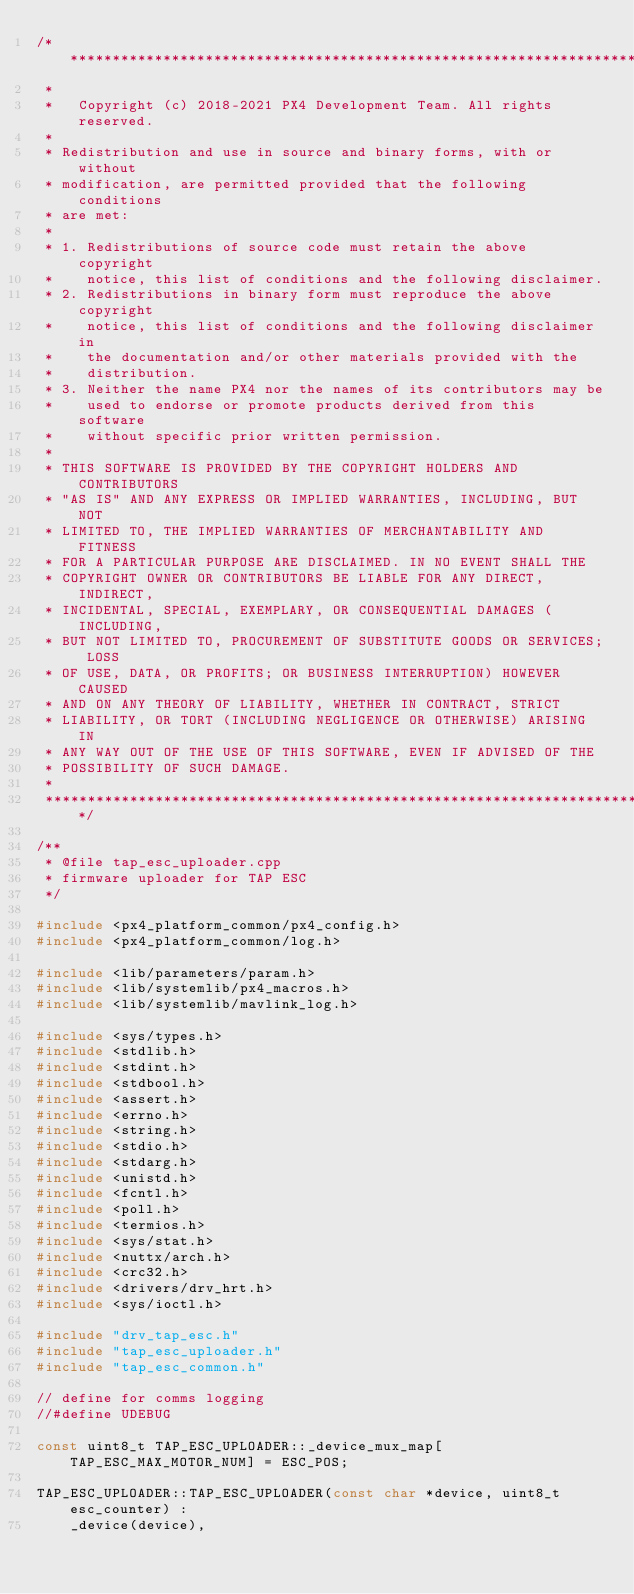<code> <loc_0><loc_0><loc_500><loc_500><_C++_>/****************************************************************************
 *
 *   Copyright (c) 2018-2021 PX4 Development Team. All rights reserved.
 *
 * Redistribution and use in source and binary forms, with or without
 * modification, are permitted provided that the following conditions
 * are met:
 *
 * 1. Redistributions of source code must retain the above copyright
 *    notice, this list of conditions and the following disclaimer.
 * 2. Redistributions in binary form must reproduce the above copyright
 *    notice, this list of conditions and the following disclaimer in
 *    the documentation and/or other materials provided with the
 *    distribution.
 * 3. Neither the name PX4 nor the names of its contributors may be
 *    used to endorse or promote products derived from this software
 *    without specific prior written permission.
 *
 * THIS SOFTWARE IS PROVIDED BY THE COPYRIGHT HOLDERS AND CONTRIBUTORS
 * "AS IS" AND ANY EXPRESS OR IMPLIED WARRANTIES, INCLUDING, BUT NOT
 * LIMITED TO, THE IMPLIED WARRANTIES OF MERCHANTABILITY AND FITNESS
 * FOR A PARTICULAR PURPOSE ARE DISCLAIMED. IN NO EVENT SHALL THE
 * COPYRIGHT OWNER OR CONTRIBUTORS BE LIABLE FOR ANY DIRECT, INDIRECT,
 * INCIDENTAL, SPECIAL, EXEMPLARY, OR CONSEQUENTIAL DAMAGES (INCLUDING,
 * BUT NOT LIMITED TO, PROCUREMENT OF SUBSTITUTE GOODS OR SERVICES; LOSS
 * OF USE, DATA, OR PROFITS; OR BUSINESS INTERRUPTION) HOWEVER CAUSED
 * AND ON ANY THEORY OF LIABILITY, WHETHER IN CONTRACT, STRICT
 * LIABILITY, OR TORT (INCLUDING NEGLIGENCE OR OTHERWISE) ARISING IN
 * ANY WAY OUT OF THE USE OF THIS SOFTWARE, EVEN IF ADVISED OF THE
 * POSSIBILITY OF SUCH DAMAGE.
 *
 ****************************************************************************/

/**
 * @file tap_esc_uploader.cpp
 * firmware uploader for TAP ESC
 */

#include <px4_platform_common/px4_config.h>
#include <px4_platform_common/log.h>

#include <lib/parameters/param.h>
#include <lib/systemlib/px4_macros.h>
#include <lib/systemlib/mavlink_log.h>

#include <sys/types.h>
#include <stdlib.h>
#include <stdint.h>
#include <stdbool.h>
#include <assert.h>
#include <errno.h>
#include <string.h>
#include <stdio.h>
#include <stdarg.h>
#include <unistd.h>
#include <fcntl.h>
#include <poll.h>
#include <termios.h>
#include <sys/stat.h>
#include <nuttx/arch.h>
#include <crc32.h>
#include <drivers/drv_hrt.h>
#include <sys/ioctl.h>

#include "drv_tap_esc.h"
#include "tap_esc_uploader.h"
#include "tap_esc_common.h"

// define for comms logging
//#define UDEBUG

const uint8_t TAP_ESC_UPLOADER::_device_mux_map[TAP_ESC_MAX_MOTOR_NUM] = ESC_POS;

TAP_ESC_UPLOADER::TAP_ESC_UPLOADER(const char *device, uint8_t esc_counter) :
	_device(device),</code> 